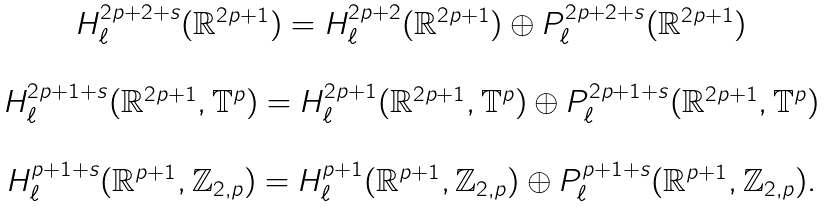Convert formula to latex. <formula><loc_0><loc_0><loc_500><loc_500>\begin{array} { c } H ^ { 2 p + 2 + s } _ { \ell } ( \mathbb { R } ^ { 2 p + 1 } ) = H ^ { 2 p + 2 } _ { \ell } ( \mathbb { R } ^ { 2 p + 1 } ) \oplus P ^ { 2 p + 2 + s } _ { \ell } ( \mathbb { R } ^ { 2 p + 1 } ) \\ \\ H ^ { 2 p + 1 + s } _ { \ell } ( \mathbb { R } ^ { 2 p + 1 } , \mathbb { T } ^ { p } ) = H ^ { 2 p + 1 } _ { \ell } ( \mathbb { R } ^ { 2 p + 1 } , \mathbb { T } ^ { p } ) \oplus P ^ { 2 p + 1 + s } _ { \ell } ( \mathbb { R } ^ { 2 p + 1 } , \mathbb { T } ^ { p } ) \\ \\ H ^ { p + 1 + s } _ { \ell } ( \mathbb { R } ^ { p + 1 } , \mathbb { Z } _ { 2 , p } ) = H ^ { p + 1 } _ { \ell } ( \mathbb { R } ^ { p + 1 } , \mathbb { Z } _ { 2 , p } ) \oplus P ^ { p + 1 + s } _ { \ell } ( \mathbb { R } ^ { p + 1 } , \mathbb { Z } _ { 2 , p } ) . \end{array}</formula> 